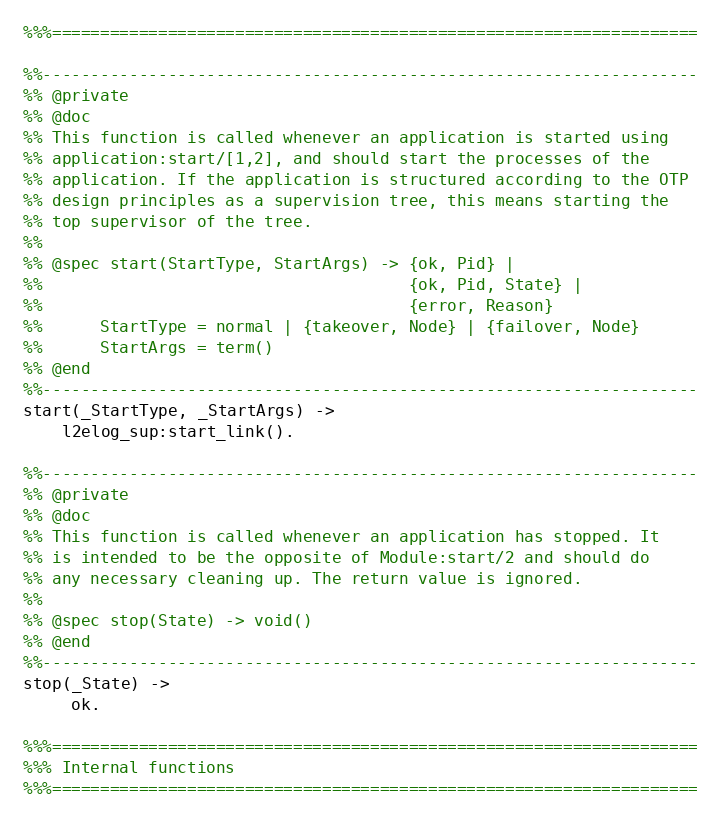Convert code to text. <code><loc_0><loc_0><loc_500><loc_500><_Erlang_>%%%===================================================================

%%--------------------------------------------------------------------
%% @private
%% @doc
%% This function is called whenever an application is started using
%% application:start/[1,2], and should start the processes of the
%% application. If the application is structured according to the OTP
%% design principles as a supervision tree, this means starting the
%% top supervisor of the tree.
%%
%% @spec start(StartType, StartArgs) -> {ok, Pid} |
%%                                      {ok, Pid, State} |
%%                                      {error, Reason}
%%      StartType = normal | {takeover, Node} | {failover, Node}
%%      StartArgs = term()
%% @end
%%--------------------------------------------------------------------
start(_StartType, _StartArgs) ->
    l2elog_sup:start_link().

%%--------------------------------------------------------------------
%% @private
%% @doc
%% This function is called whenever an application has stopped. It
%% is intended to be the opposite of Module:start/2 and should do
%% any necessary cleaning up. The return value is ignored.
%%
%% @spec stop(State) -> void()
%% @end
%%--------------------------------------------------------------------
stop(_State) ->
     ok.

%%%===================================================================
%%% Internal functions
%%%===================================================================
</code> 